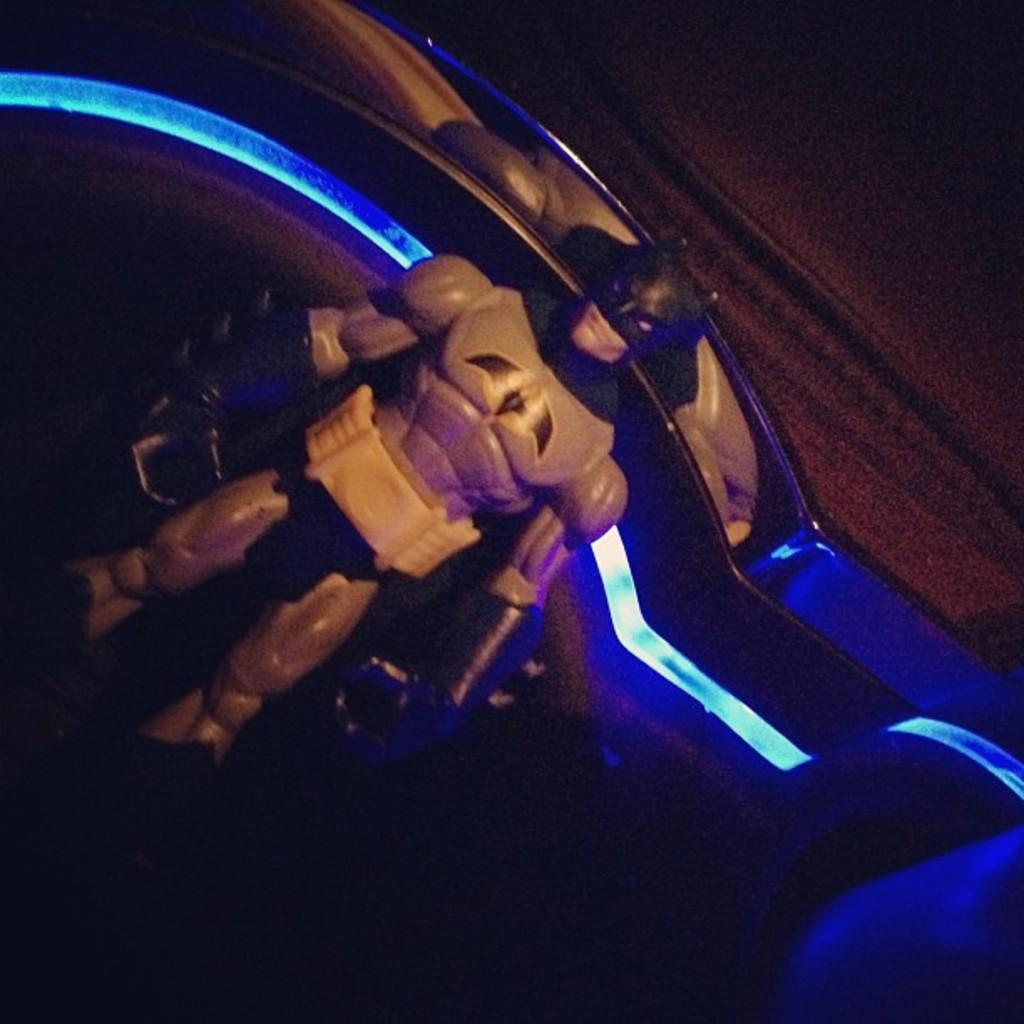What is the main subject of the image? The main subject of the image is a batsman's statue. Where is the statue located in relation to other objects in the image? The statue is placed near a wall. What type of sock is the owl wearing on its left foot in the image? There is no owl or sock present in the image; it features a batsman's statue placed near a wall. 